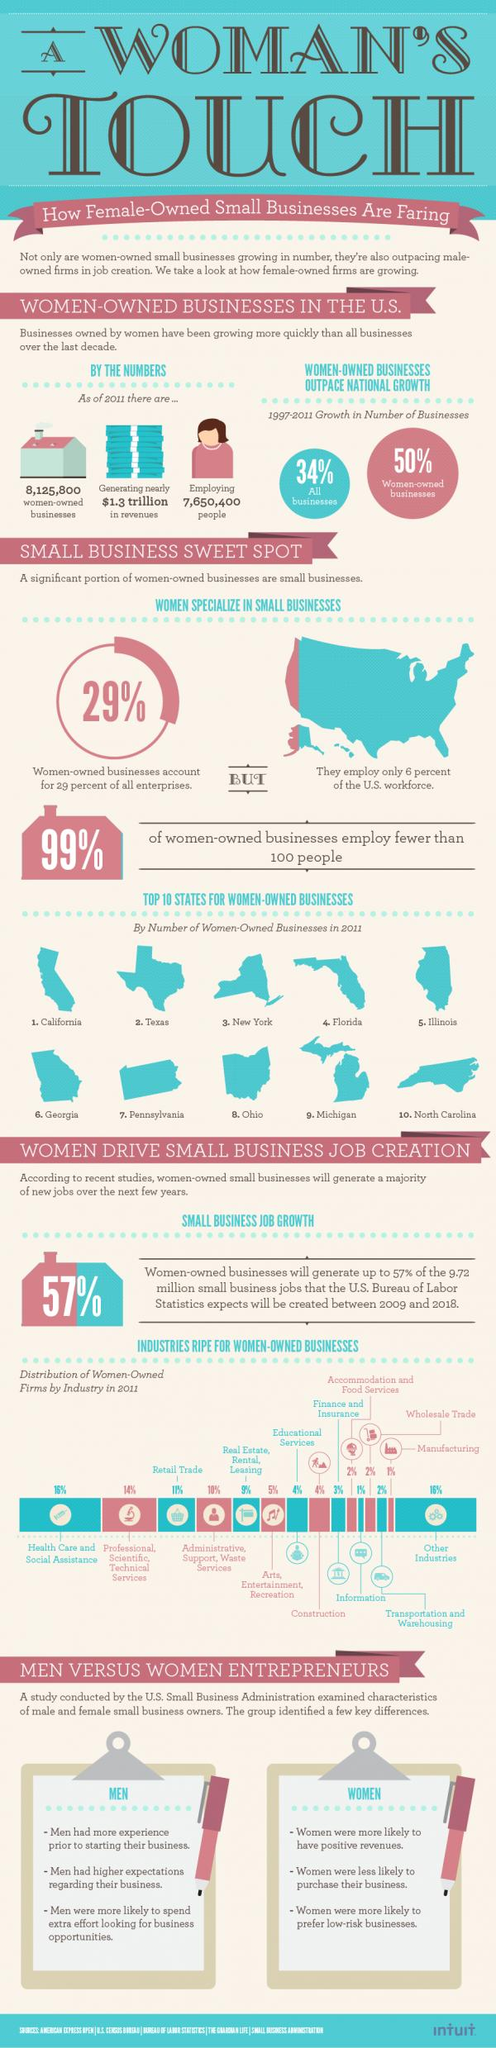Draw attention to some important aspects in this diagram. According to statistics, women-owned industries in healthcare and other sectors have a distribution rate of approximately 16%. According to recent data, only 1% of women-owned businesses employ over 100 workers. In industries with a distribution rate of 4%, Educational Services and Construction are two examples of industries that have low distribution rates. 